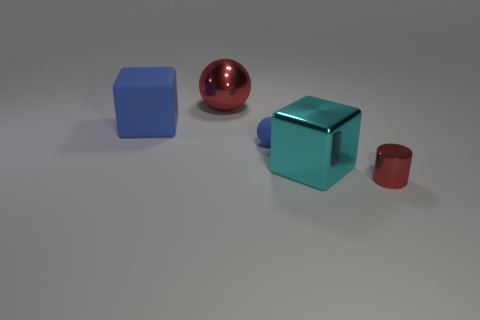Add 3 small matte balls. How many objects exist? 8 Subtract all blocks. How many objects are left? 3 Subtract 1 blocks. How many blocks are left? 1 Subtract all blue blocks. How many blocks are left? 1 Subtract all tiny rubber spheres. Subtract all gray rubber cubes. How many objects are left? 4 Add 2 big cyan cubes. How many big cyan cubes are left? 3 Add 1 yellow rubber objects. How many yellow rubber objects exist? 1 Subtract 0 green cubes. How many objects are left? 5 Subtract all green cylinders. Subtract all blue spheres. How many cylinders are left? 1 